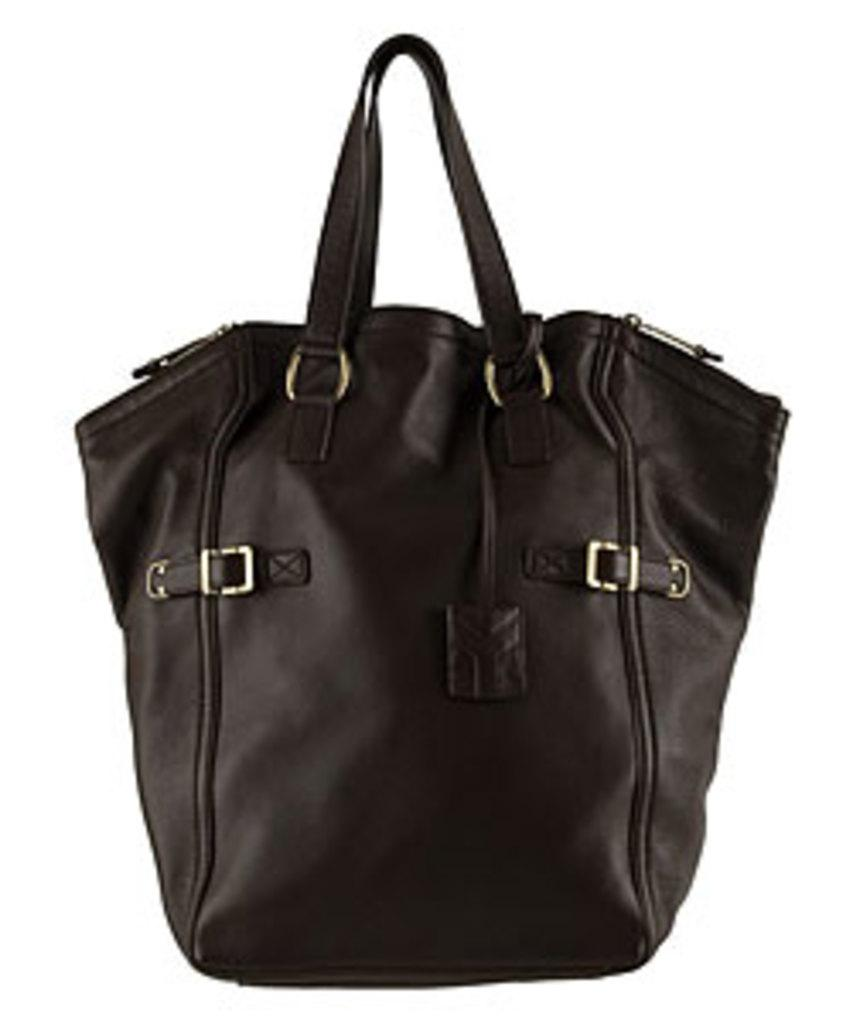What object can be seen in the image? There is a bag in the image. What type of bait is being used by the zebra in the image? There is no zebra present in the image, and therefore no bait can be observed. 